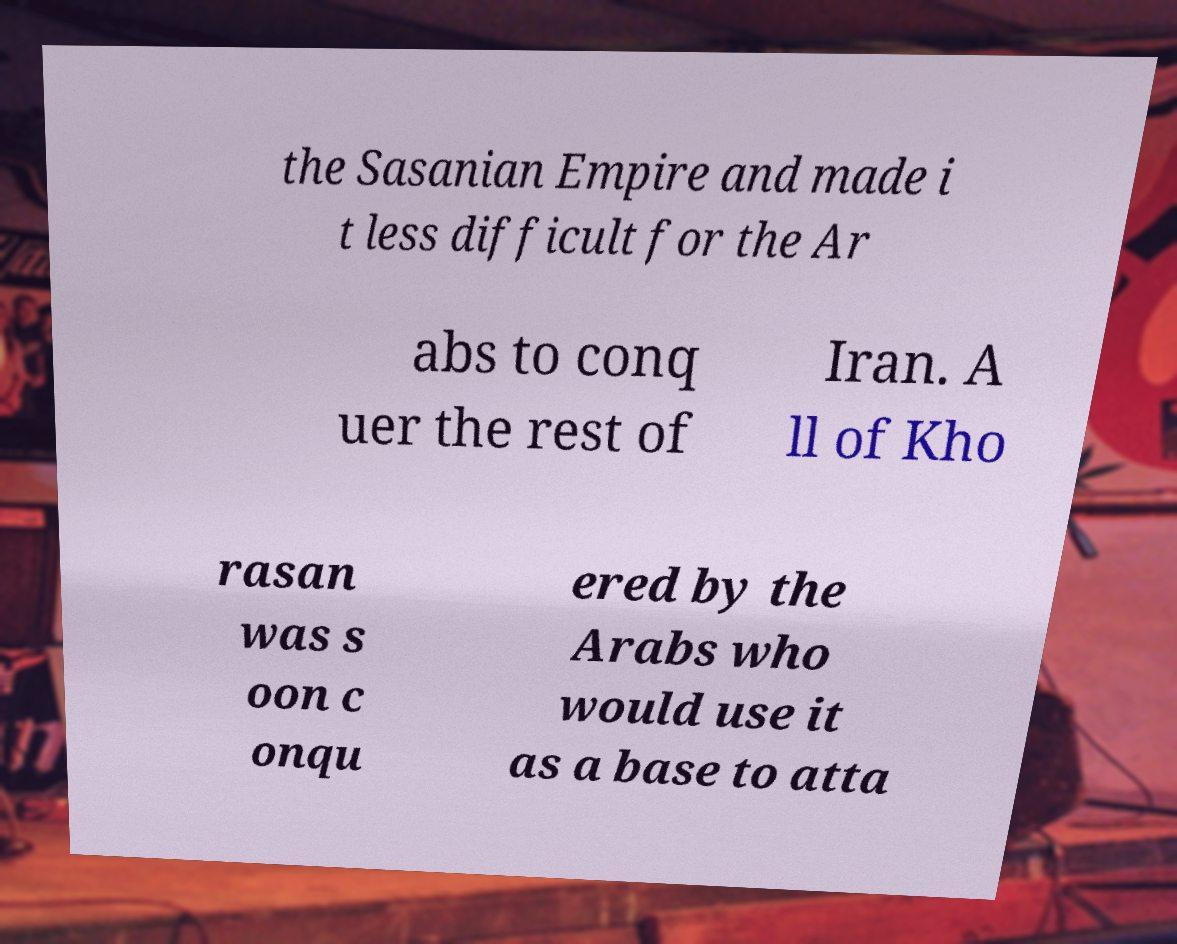Could you extract and type out the text from this image? the Sasanian Empire and made i t less difficult for the Ar abs to conq uer the rest of Iran. A ll of Kho rasan was s oon c onqu ered by the Arabs who would use it as a base to atta 